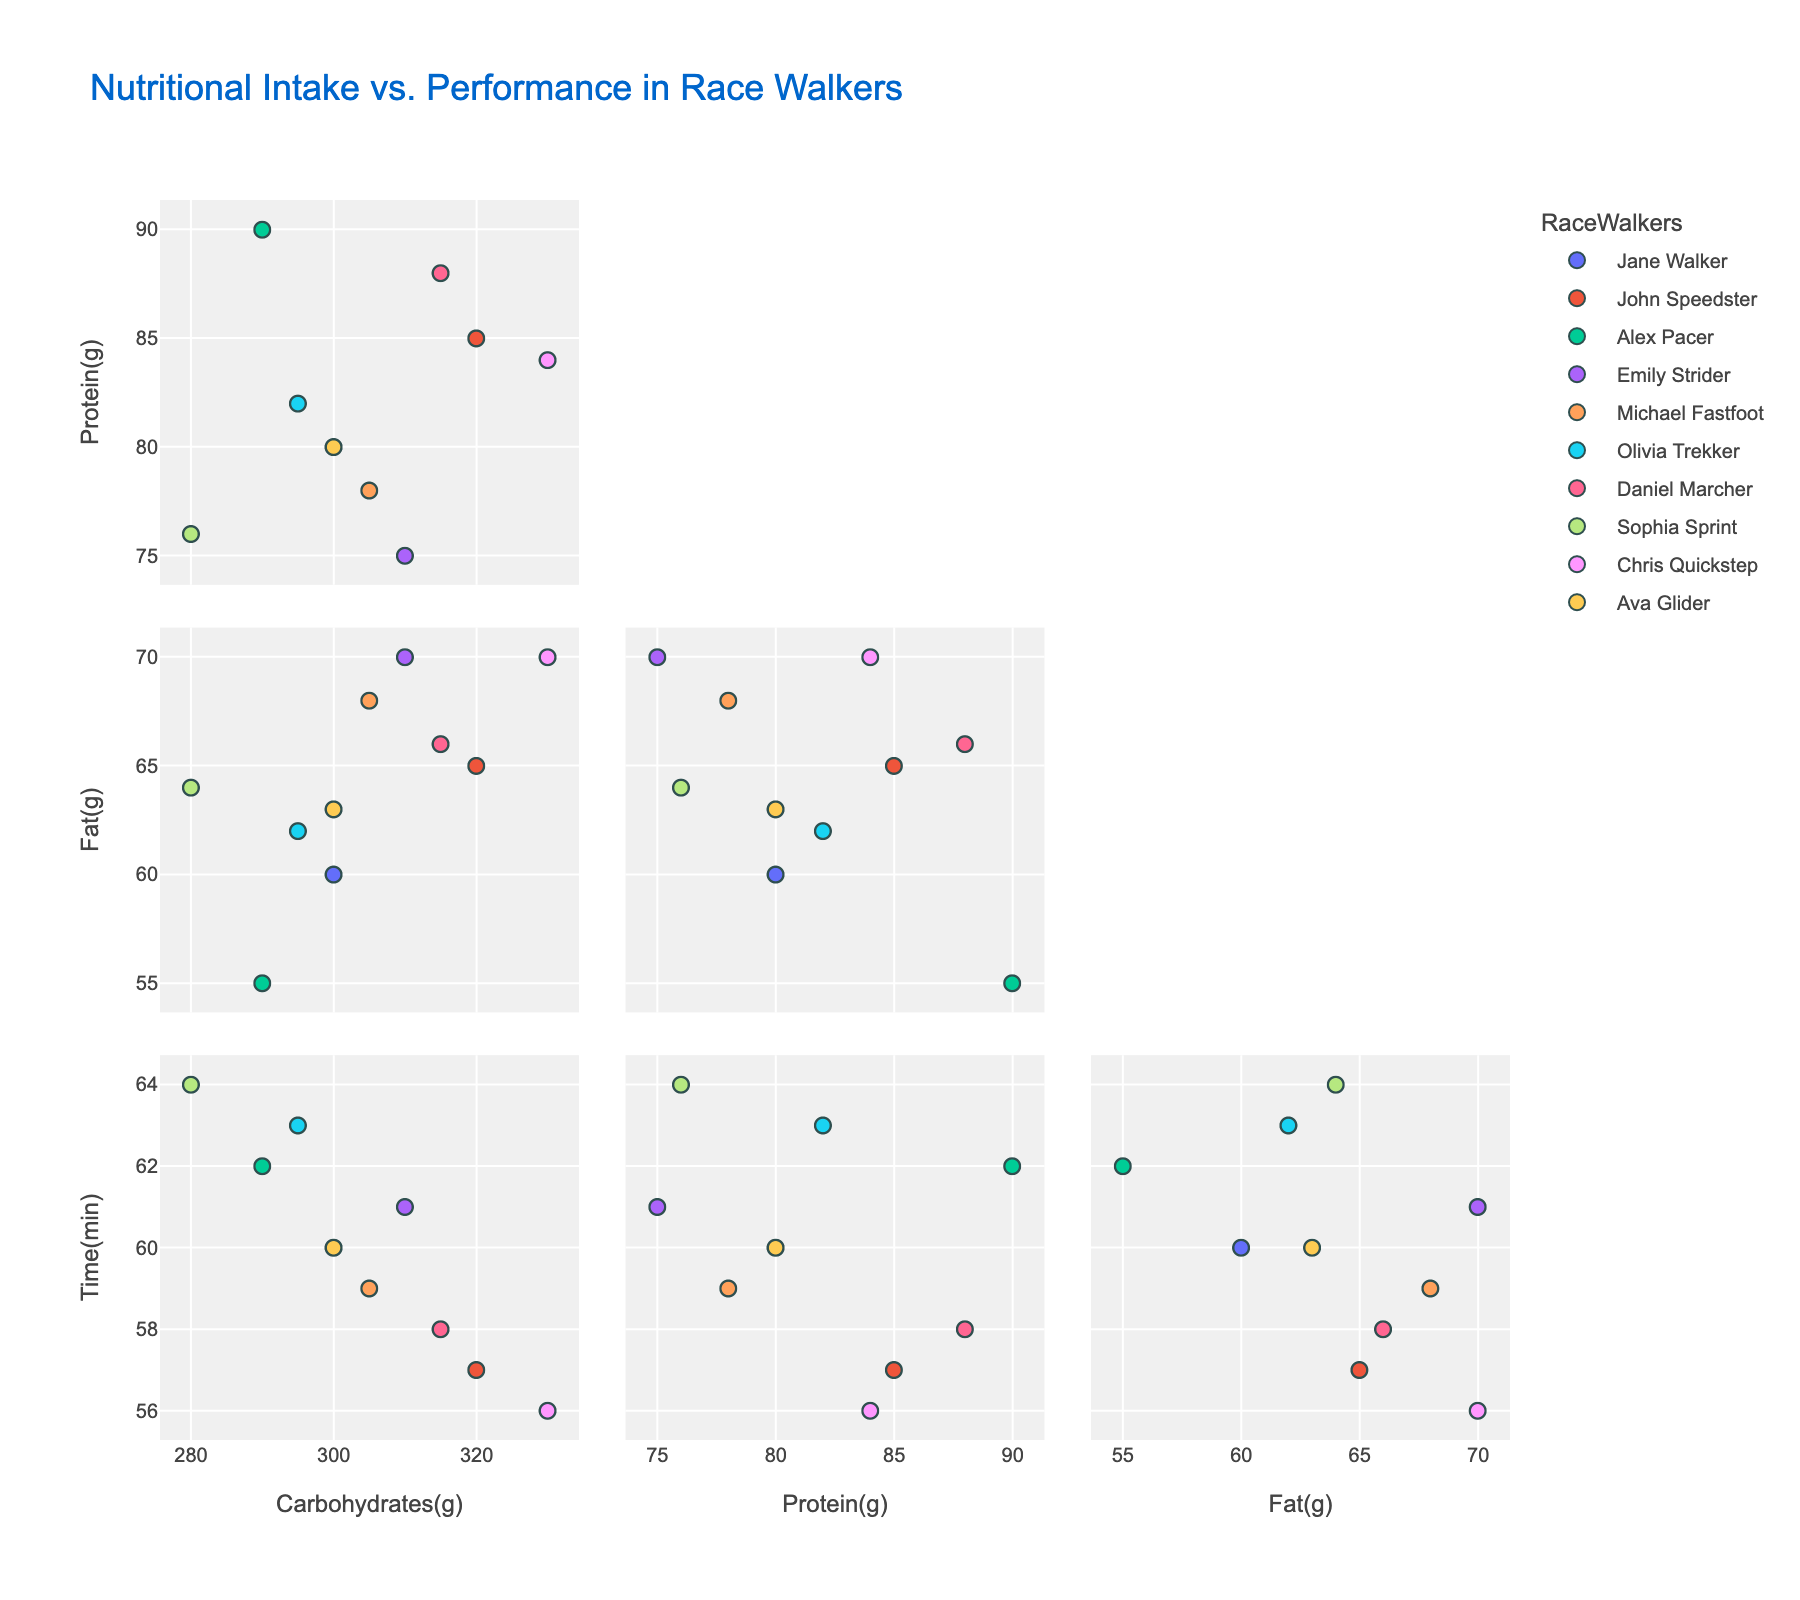What is the title of the graph? The title of the graph is usually placed at the top of the figure in a prominent font size and states the overall purpose or content of the graph.
Answer: Nutritional Intake vs. Performance in Race Walkers How many data points are plotted in the scatter plot matrix? Look at the number of race walkers listed in the data table and count the total. There are 10 race walkers.
Answer: 10 Which race walker has the highest carbohydrate intake? Identify the data point with the highest value on the 'NutritionalIntake_Carbohydrates(g)' axis. Chris Quickstep has a carbohydrate intake of 330g, which is the highest.
Answer: Chris Quickstep How does the protein intake generally relate to race performance time? Observe the trend in the scatter plots that compare 'NutritionalIntake_Protein(g)' with 'RacePerformance_Time(min)'. Generally, as protein intake increases, race performance time slightly improves (decreases).
Answer: As protein increases, time decreases slightly Who has both the lowest race performance time and high carbohydrate intake? Look for the lowest point on the 'RacePerformance_Time(min)' axis and check the corresponding 'NutritionalIntake_Carbohydrates(g)'. Chris Quickstep has the lowest race performance time of 56 minutes with carbohydrate intake of 330g.
Answer: Chris Quickstep Is there an outlier in the fat intake among race walkers? Look at the scatter plot of 'NutritionalIntake_Fat(g)'; outliers are points that significantly deviate from other data points. Sophia Sprint has a lower fat intake of 55g, while others range between 60-70g.
Answer: Sophia Sprint What is the general trend between fat intake and race performance time? Examine the scatter plot that compares 'NutritionalIntake_Fat(g)' with 'RacePerformance_Time(min)' for a visible trend. Generally, those with lower fat intake tend to have longer race performance times.
Answer: Lower fat intake, longer times What's the ratio of carbohydrates to protein for Olivia Trekker? Divide Olivia Trekker's carbohydrate intake by her protein intake: 295g / 82g.
Answer: 3.6 Which two nutritional metrics seem most closely correlated with each other, based on the scatter plot matrix? Look for scatter plots among the four metrics where the points form a closer cluster or linear relationship. Carbohydrates and protein appear to have a strong positive correlation.
Answer: Carbohydrates and Protein Who is the fastest race walker, and what is their nutritional profile like? Identify the race walker with the lowest 'RacePerformance_Time(min)' and check their nutritional intake data. Chris Quickstep at 56 minutes, with 330g carbohydrates, 84g protein, and 70g fat intake.
Answer: Chris Quickstep, 330g carbs, 84g protein, 70g fat 